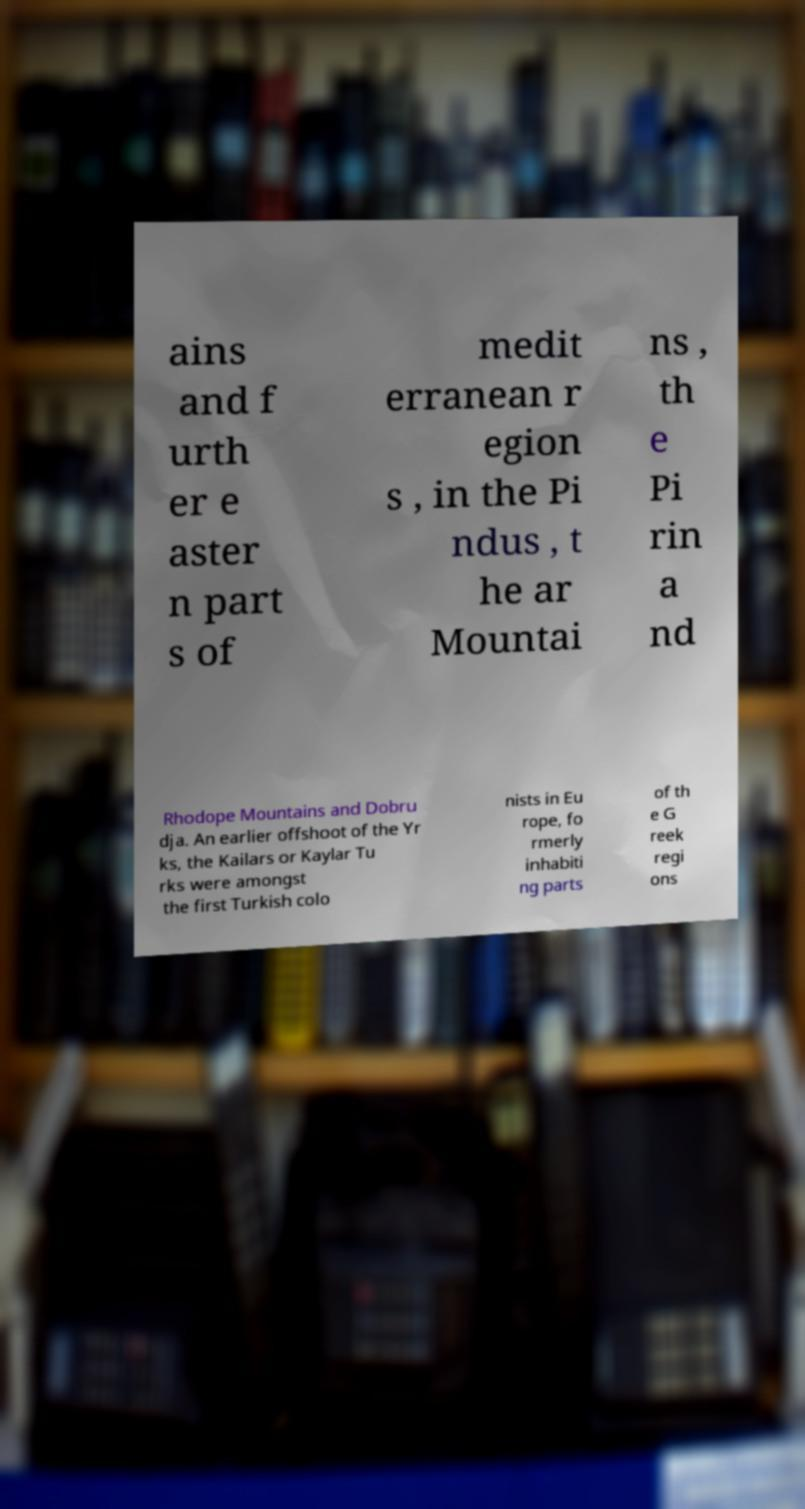Can you accurately transcribe the text from the provided image for me? ains and f urth er e aster n part s of medit erranean r egion s , in the Pi ndus , t he ar Mountai ns , th e Pi rin a nd Rhodope Mountains and Dobru dja. An earlier offshoot of the Yr ks, the Kailars or Kaylar Tu rks were amongst the first Turkish colo nists in Eu rope, fo rmerly inhabiti ng parts of th e G reek regi ons 